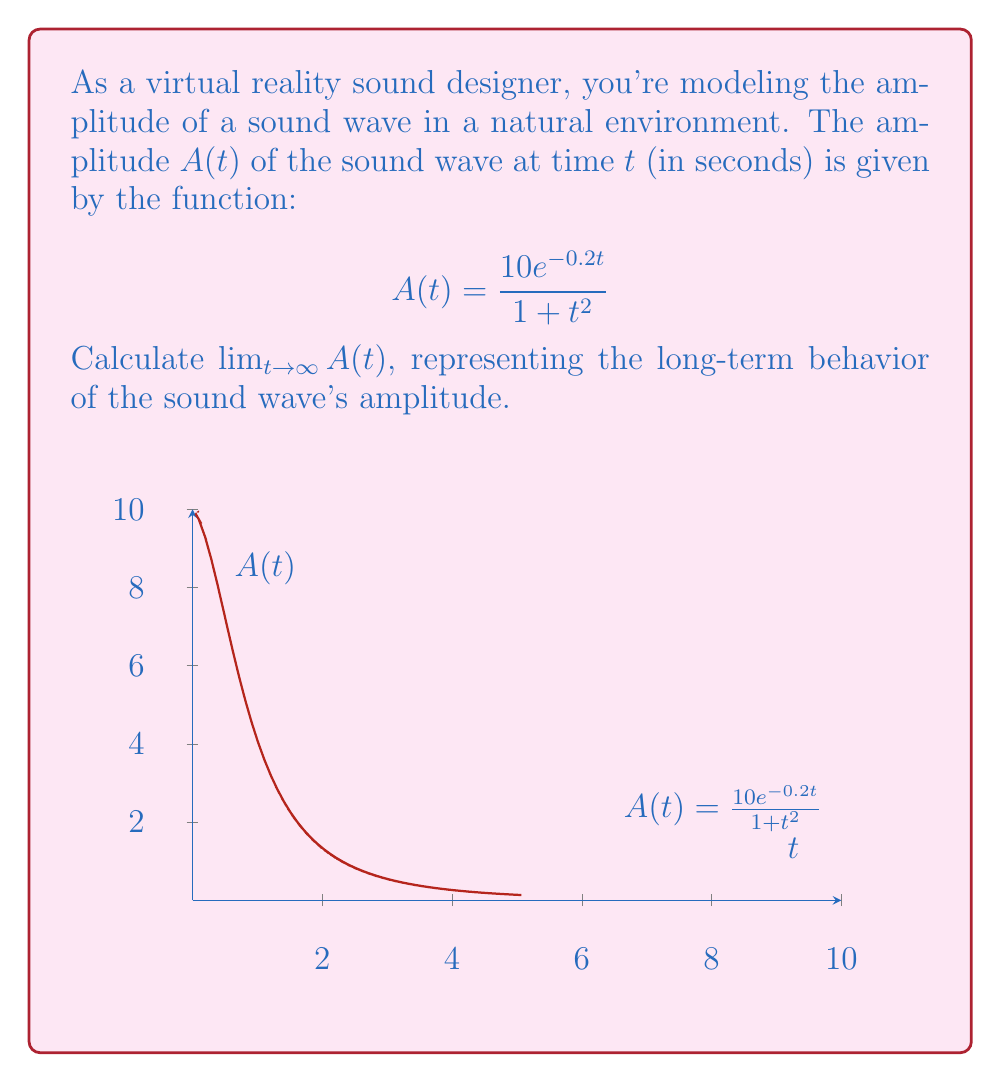Provide a solution to this math problem. To find the limit as $t$ approaches infinity, let's analyze the function:

1) First, let's consider the numerator and denominator separately:

   Numerator: $10e^{-0.2t}$
   Denominator: $1 + t^2$

2) As $t \to \infty$:
   - $e^{-0.2t} \to 0$ (exponential decay)
   - $1 + t^2 \to \infty$ (polynomial growth)

3) We have a situation where both numerator and denominator approach extreme values. Let's use L'Hôpital's rule:

   $$\lim_{t \to \infty} \frac{10e^{-0.2t}}{1 + t^2} = \lim_{t \to \infty} \frac{10 \cdot (-0.2)e^{-0.2t}}{2t}$$

4) Simplifying:

   $$\lim_{t \to \infty} \frac{-2e^{-0.2t}}{t}$$

5) Apply L'Hôpital's rule again:

   $$\lim_{t \to \infty} \frac{-2 \cdot (-0.2)e^{-0.2t}}{1} = \lim_{t \to \infty} 0.4e^{-0.2t}$$

6) As $t \to \infty$, $e^{-0.2t} \to 0$, so:

   $$\lim_{t \to \infty} 0.4e^{-0.2t} = 0$$

Therefore, the amplitude of the sound wave approaches 0 as time goes to infinity, which is consistent with the behavior of natural sound waves that decay over time.
Answer: $0$ 